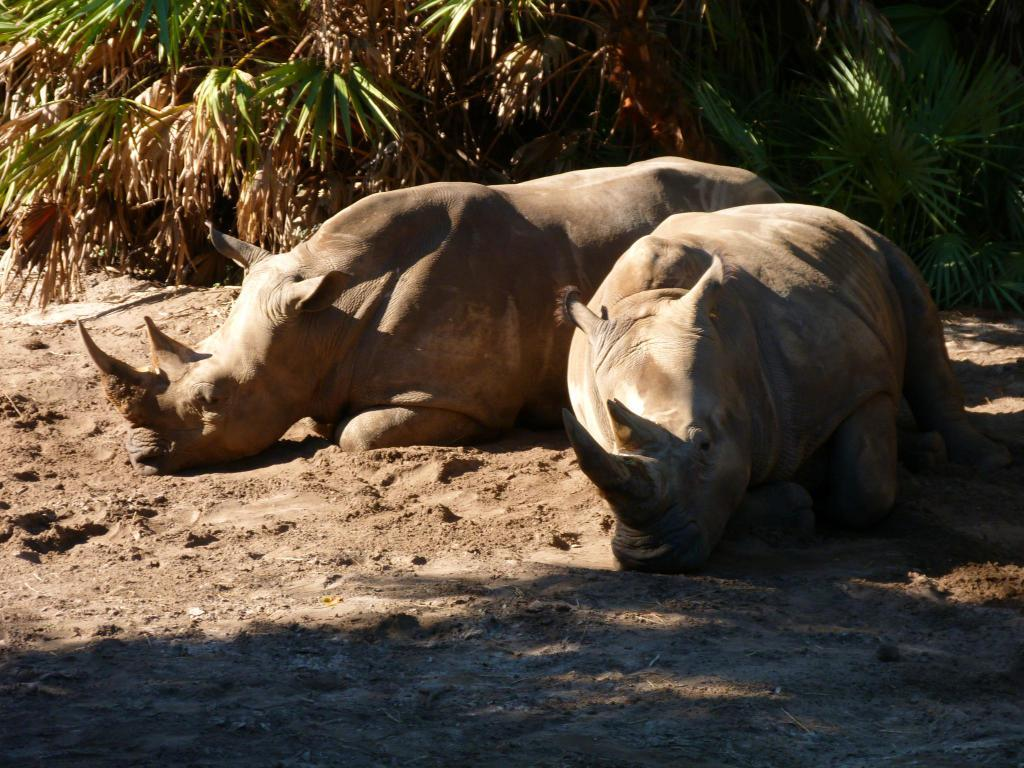What animals are present in the image? There are two rhinoceros in the image. What can be seen in the background of the image? Plants are visible in the background of the image. What type of dock can be seen in the image? There is no dock present in the image; it features two rhinoceros and plants in the background. 